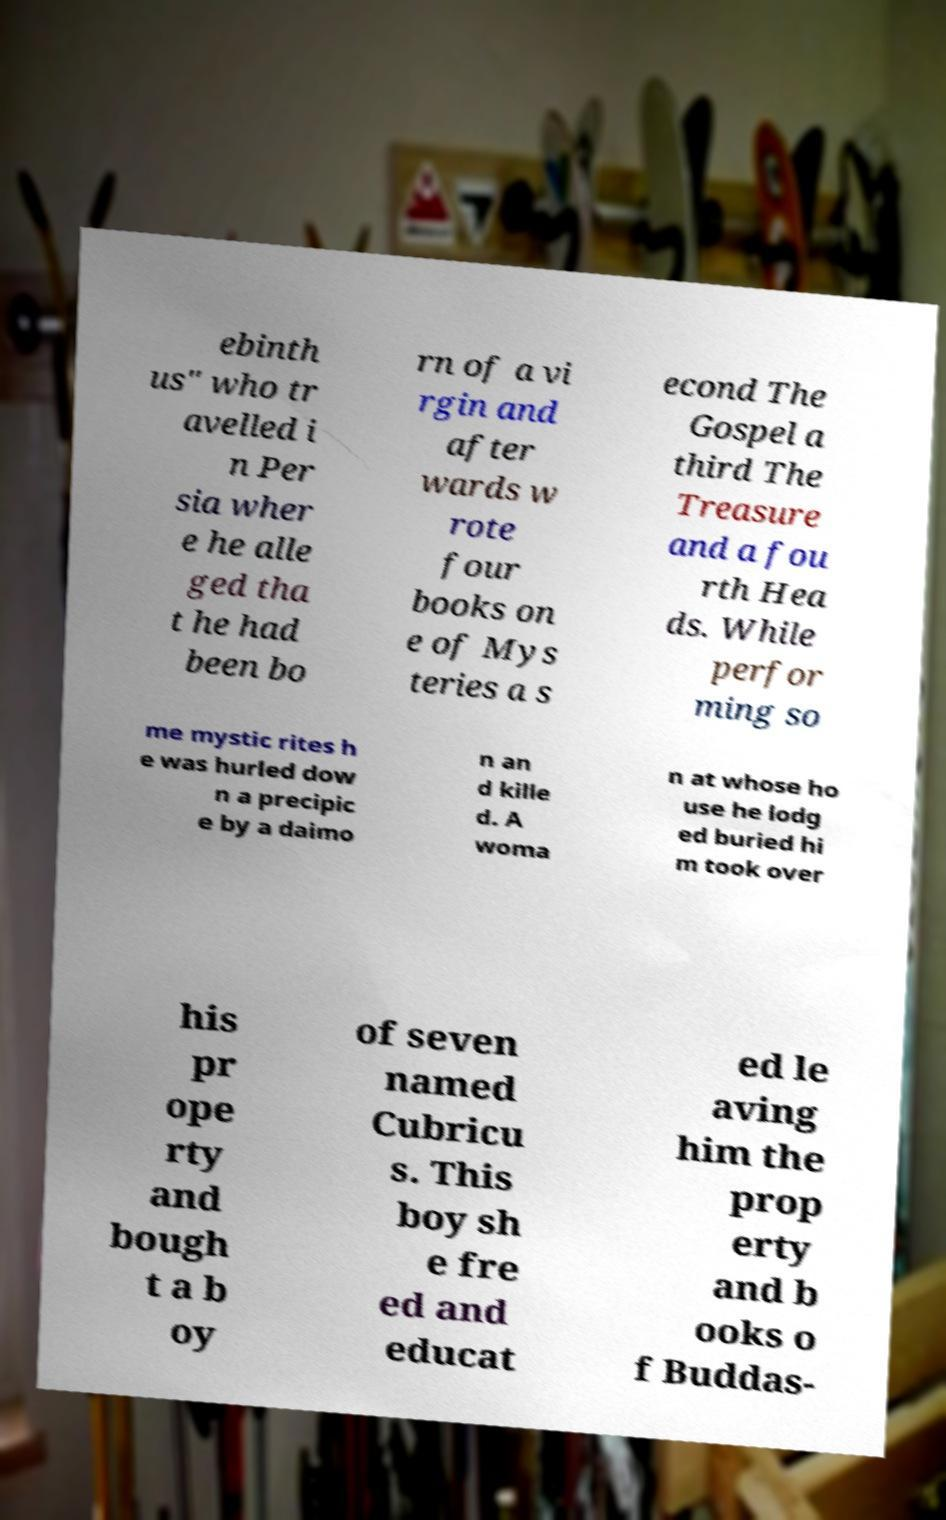Can you accurately transcribe the text from the provided image for me? ebinth us" who tr avelled i n Per sia wher e he alle ged tha t he had been bo rn of a vi rgin and after wards w rote four books on e of Mys teries a s econd The Gospel a third The Treasure and a fou rth Hea ds. While perfor ming so me mystic rites h e was hurled dow n a precipic e by a daimo n an d kille d. A woma n at whose ho use he lodg ed buried hi m took over his pr ope rty and bough t a b oy of seven named Cubricu s. This boy sh e fre ed and educat ed le aving him the prop erty and b ooks o f Buddas- 